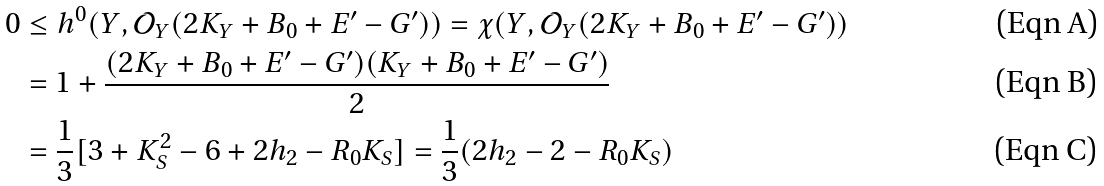<formula> <loc_0><loc_0><loc_500><loc_500>0 & \leq h ^ { 0 } ( Y , \mathcal { O } _ { Y } ( 2 K _ { Y } + B _ { 0 } + E ^ { \prime } - G ^ { \prime } ) ) = \chi ( Y , \mathcal { O } _ { Y } ( 2 K _ { Y } + B _ { 0 } + E ^ { \prime } - G ^ { \prime } ) ) \\ & = 1 + \frac { ( 2 K _ { Y } + B _ { 0 } + E ^ { \prime } - G ^ { \prime } ) ( K _ { Y } + B _ { 0 } + E ^ { \prime } - G ^ { \prime } ) } 2 \\ & = \frac { 1 } { 3 } [ 3 + K _ { S } ^ { 2 } - 6 + 2 h _ { 2 } - R _ { 0 } K _ { S } ] = \frac { 1 } { 3 } ( 2 h _ { 2 } - 2 - R _ { 0 } K _ { S } )</formula> 